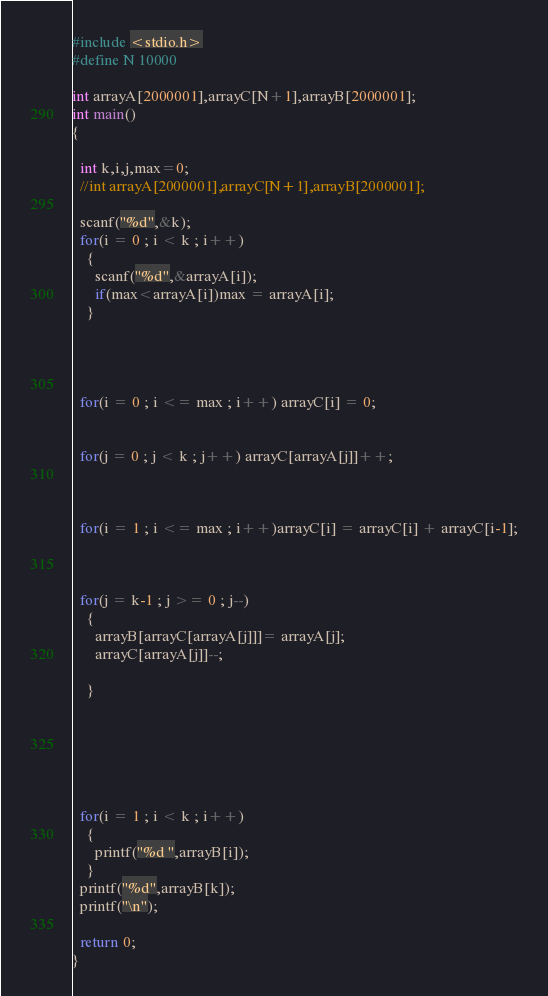<code> <loc_0><loc_0><loc_500><loc_500><_C_>#include <stdio.h>
#define N 10000

int arrayA[2000001],arrayC[N+1],arrayB[2000001];
int main()
{

  int k,i,j,max=0;
  //int arrayA[2000001],arrayC[N+1],arrayB[2000001];

  scanf("%d",&k);
  for(i = 0 ; i < k ; i++)
    {
      scanf("%d",&arrayA[i]);
      if(max<arrayA[i])max = arrayA[i];
    }




  for(i = 0 ; i <= max ; i++) arrayC[i] = 0;


  for(j = 0 ; j < k ; j++) arrayC[arrayA[j]]++;



  for(i = 1 ; i <= max ; i++)arrayC[i] = arrayC[i] + arrayC[i-1];



  for(j = k-1 ; j >= 0 ; j--)
    {
      arrayB[arrayC[arrayA[j]]]= arrayA[j];
      arrayC[arrayA[j]]--;

    }






  for(i = 1 ; i < k ; i++)
    {
      printf("%d ",arrayB[i]);
    }
  printf("%d",arrayB[k]);
  printf("\n");

  return 0;
}
</code> 